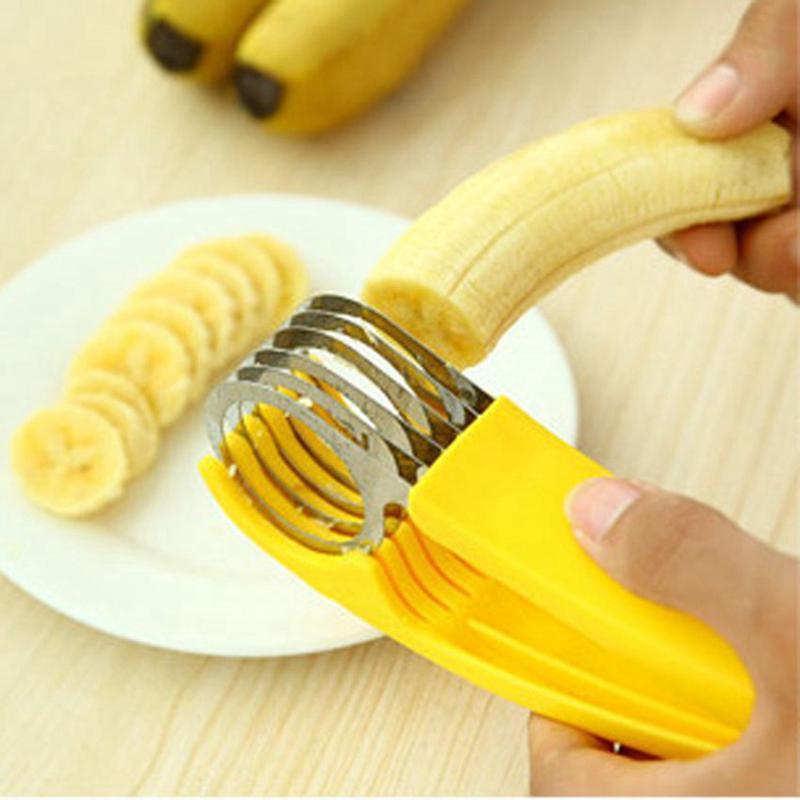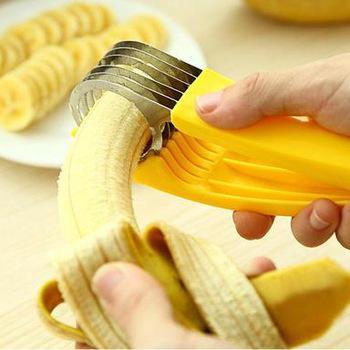The first image is the image on the left, the second image is the image on the right. Examine the images to the left and right. Is the description "Someone is placing a banana in a banana slicer in at least one of the pictures." accurate? Answer yes or no. Yes. The first image is the image on the left, the second image is the image on the right. For the images displayed, is the sentence "Only fake bananas shown." factually correct? Answer yes or no. No. 